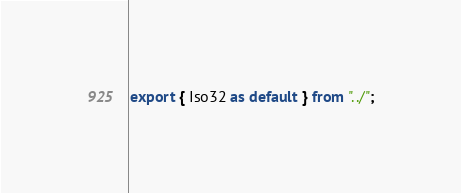<code> <loc_0><loc_0><loc_500><loc_500><_TypeScript_>export { Iso32 as default } from "../";
</code> 